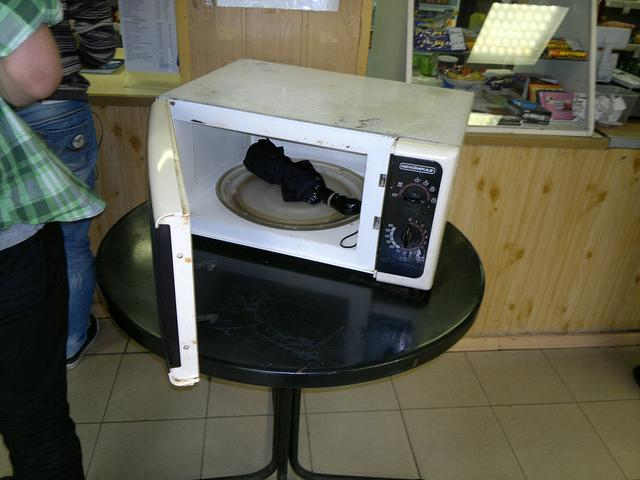Inside what is the umbrella?

Choices:
A) toaster
B) microwave
C) umbrella stand
D) dishwasher microwave 